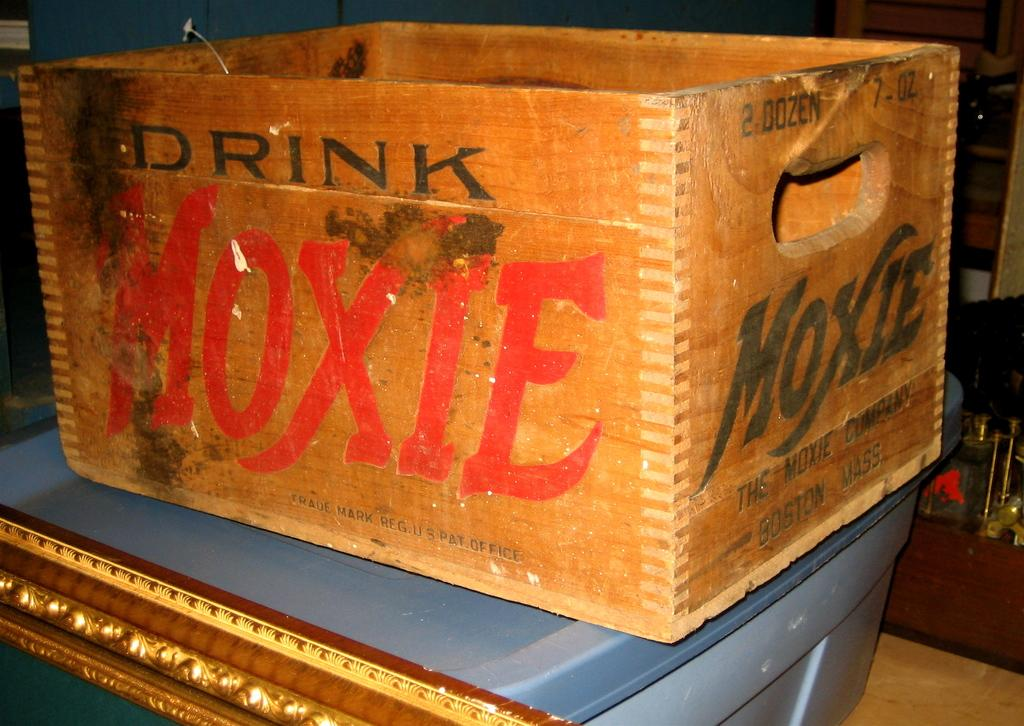<image>
Create a compact narrative representing the image presented. the word moxie that is on the box with a blue table 